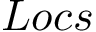Convert formula to latex. <formula><loc_0><loc_0><loc_500><loc_500>L o c s</formula> 